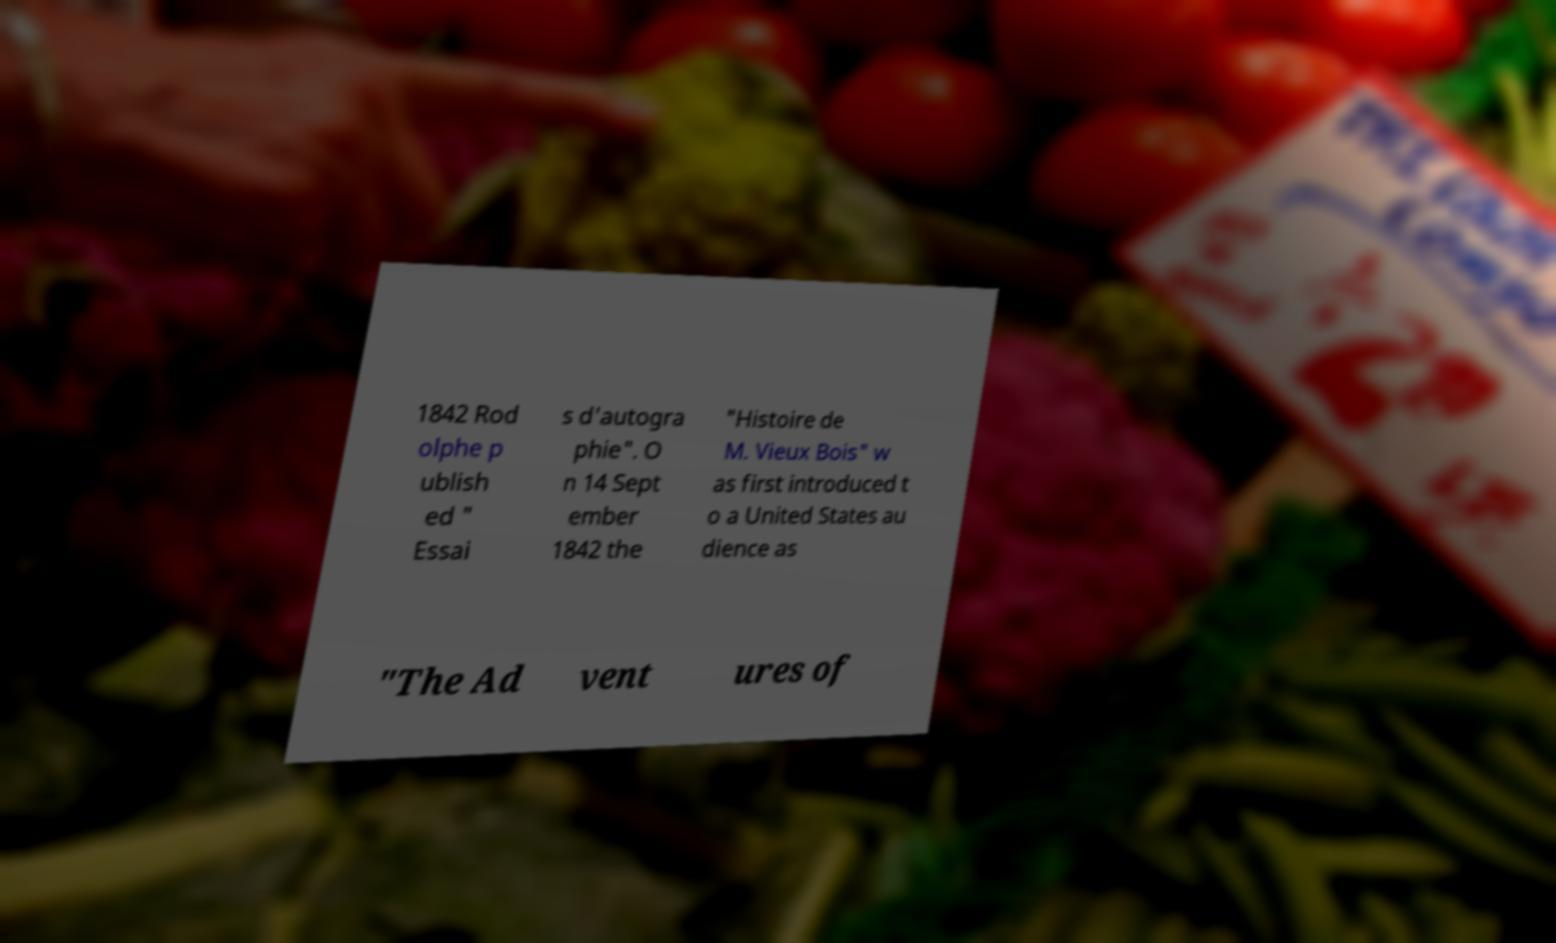For documentation purposes, I need the text within this image transcribed. Could you provide that? 1842 Rod olphe p ublish ed " Essai s d'autogra phie". O n 14 Sept ember 1842 the "Histoire de M. Vieux Bois" w as first introduced t o a United States au dience as "The Ad vent ures of 